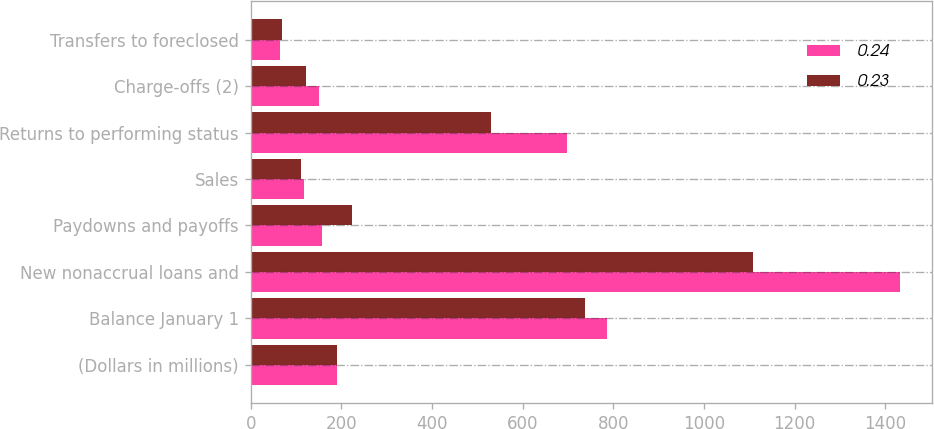Convert chart to OTSL. <chart><loc_0><loc_0><loc_500><loc_500><stacked_bar_chart><ecel><fcel>(Dollars in millions)<fcel>Balance January 1<fcel>New nonaccrual loans and<fcel>Paydowns and payoffs<fcel>Sales<fcel>Returns to performing status<fcel>Charge-offs (2)<fcel>Transfers to foreclosed<nl><fcel>0.24<fcel>190<fcel>785<fcel>1432<fcel>157<fcel>117<fcel>698<fcel>150<fcel>65<nl><fcel>0.23<fcel>190<fcel>738<fcel>1108<fcel>223<fcel>112<fcel>531<fcel>121<fcel>69<nl></chart> 